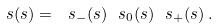<formula> <loc_0><loc_0><loc_500><loc_500>\ s ( s ) = \ s _ { - } ( s ) \ s _ { 0 } ( s ) \ s _ { + } ( s ) \, .</formula> 